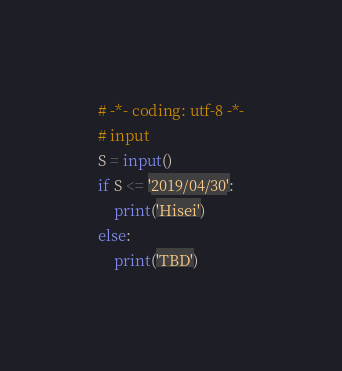<code> <loc_0><loc_0><loc_500><loc_500><_Python_># -*- coding: utf-8 -*-
# input
S = input()
if S <= '2019/04/30':
    print('Hisei')
else:
    print('TBD')
</code> 